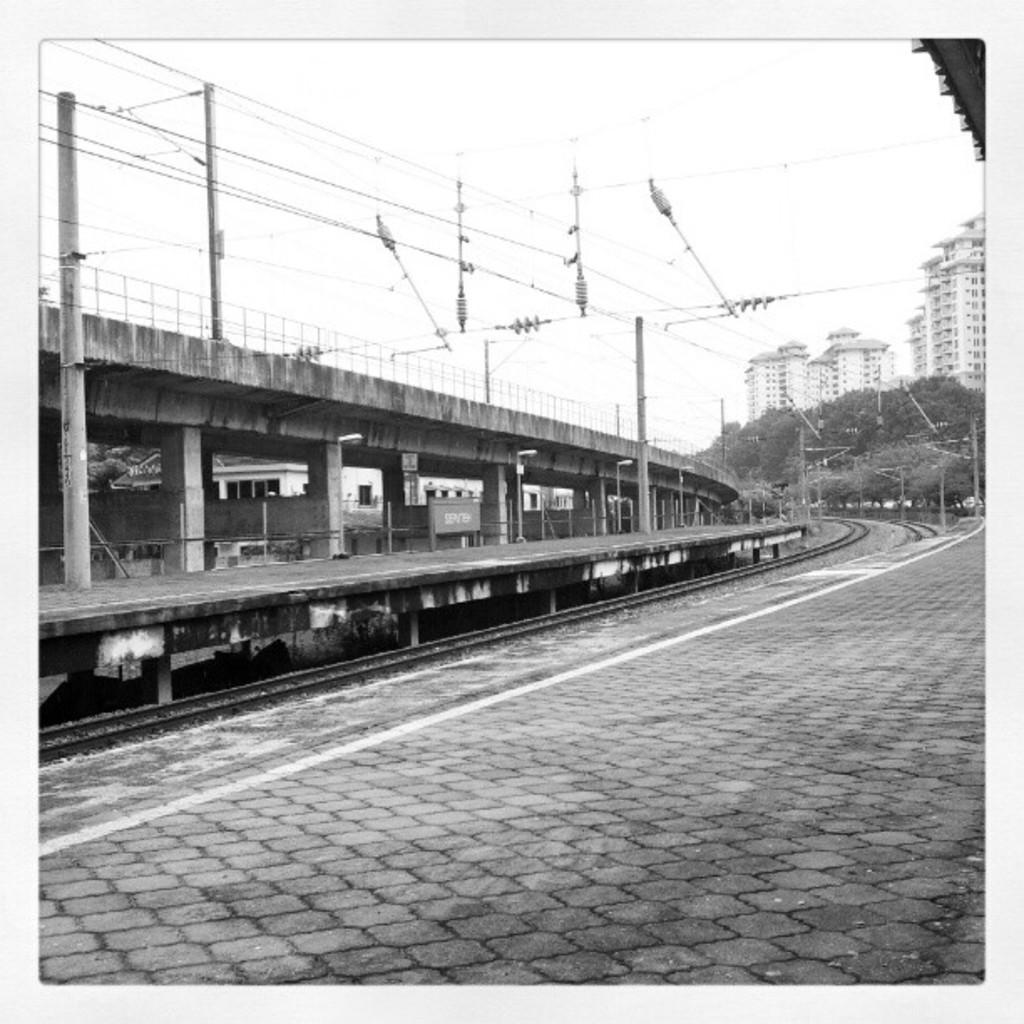Please provide a concise description of this image. In this image, we can see railway tracks in between platforms. There is a bridge on the left side of the image. There are buildings on the right side of the image. There are wires in the middle of the image. In the background of the image, there is a sky. There are poles on the platform. 